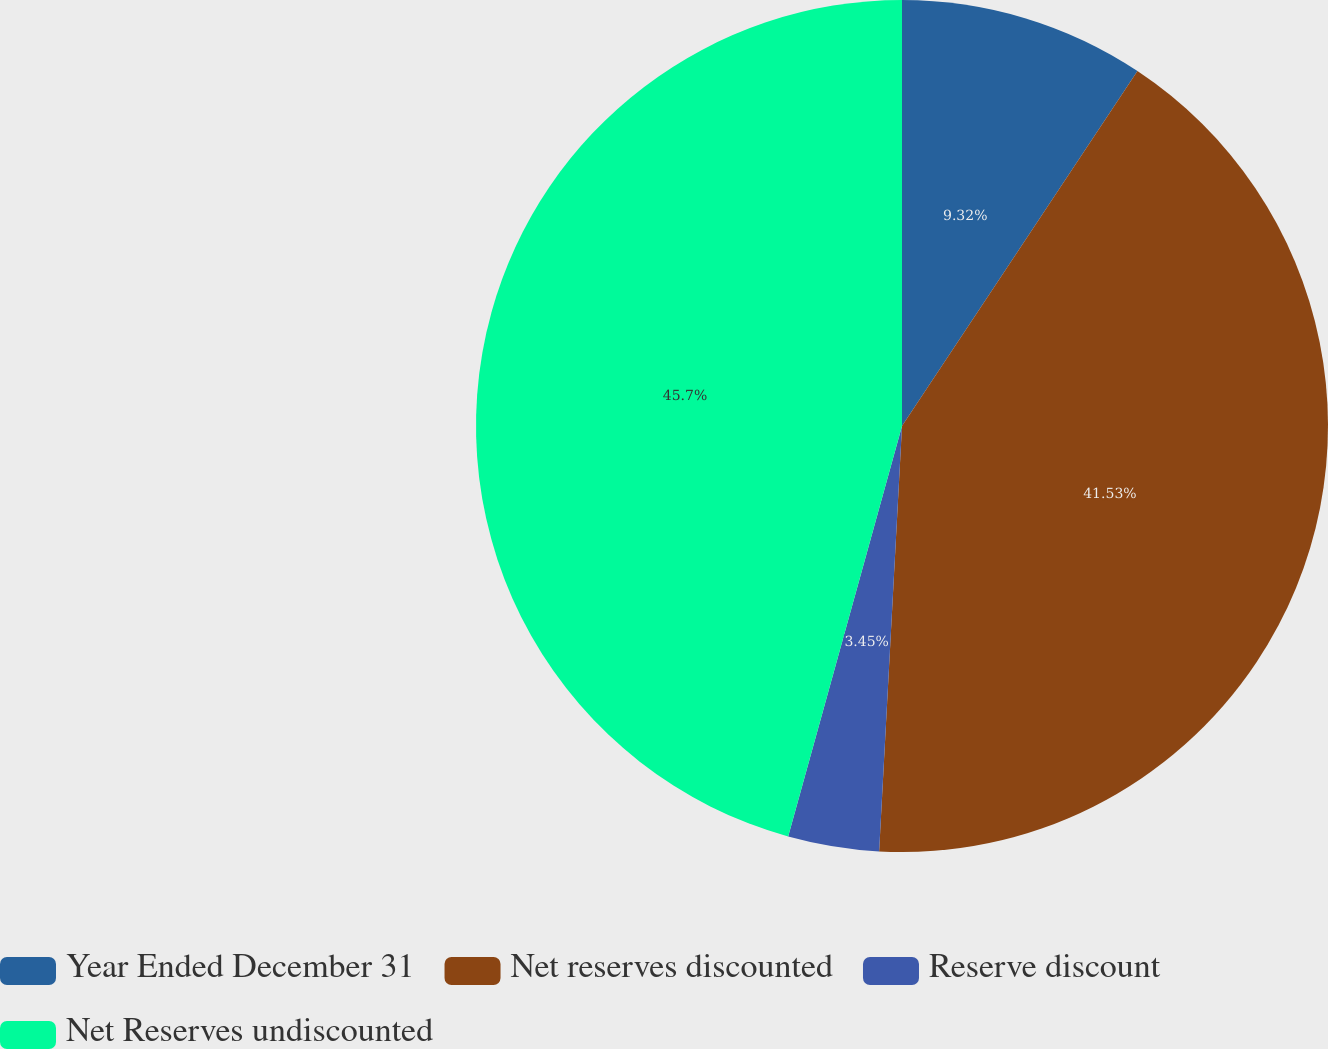Convert chart. <chart><loc_0><loc_0><loc_500><loc_500><pie_chart><fcel>Year Ended December 31<fcel>Net reserves discounted<fcel>Reserve discount<fcel>Net Reserves undiscounted<nl><fcel>9.32%<fcel>41.53%<fcel>3.45%<fcel>45.69%<nl></chart> 